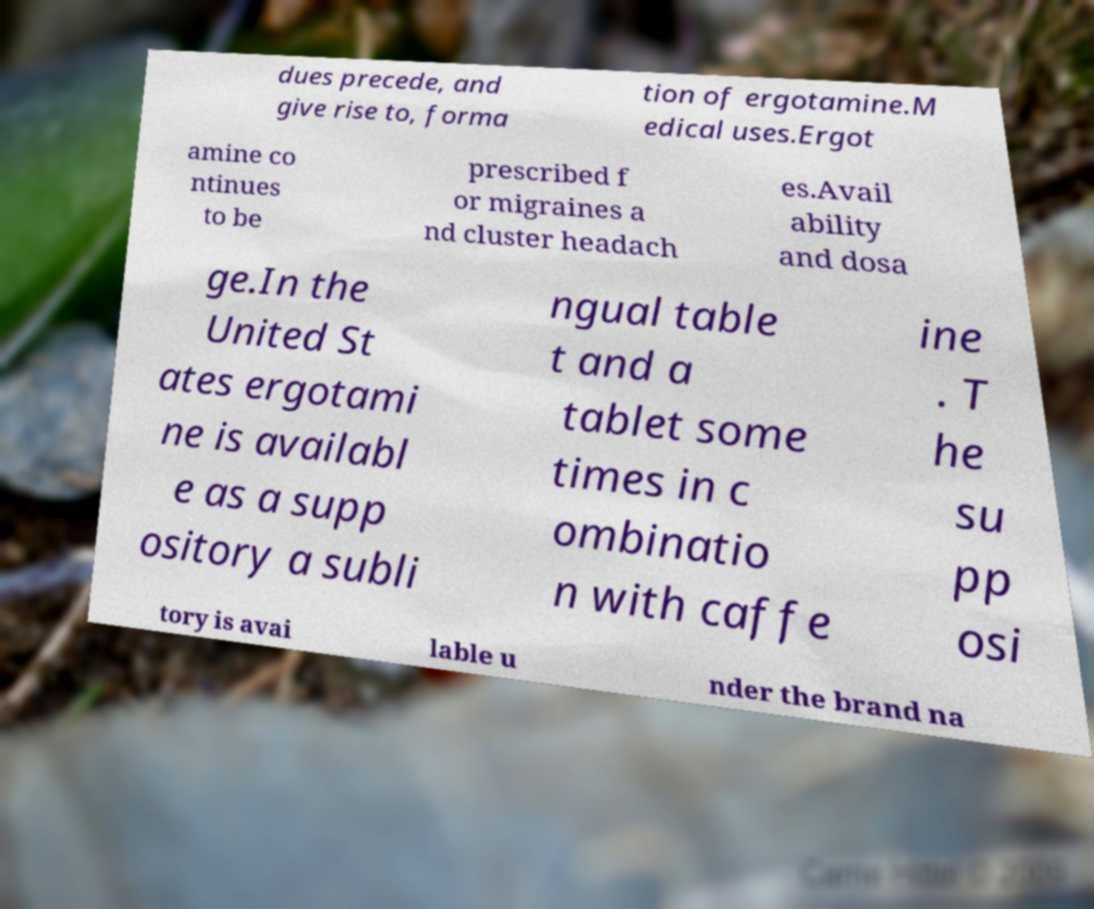What messages or text are displayed in this image? I need them in a readable, typed format. dues precede, and give rise to, forma tion of ergotamine.M edical uses.Ergot amine co ntinues to be prescribed f or migraines a nd cluster headach es.Avail ability and dosa ge.In the United St ates ergotami ne is availabl e as a supp ository a subli ngual table t and a tablet some times in c ombinatio n with caffe ine . T he su pp osi tory is avai lable u nder the brand na 